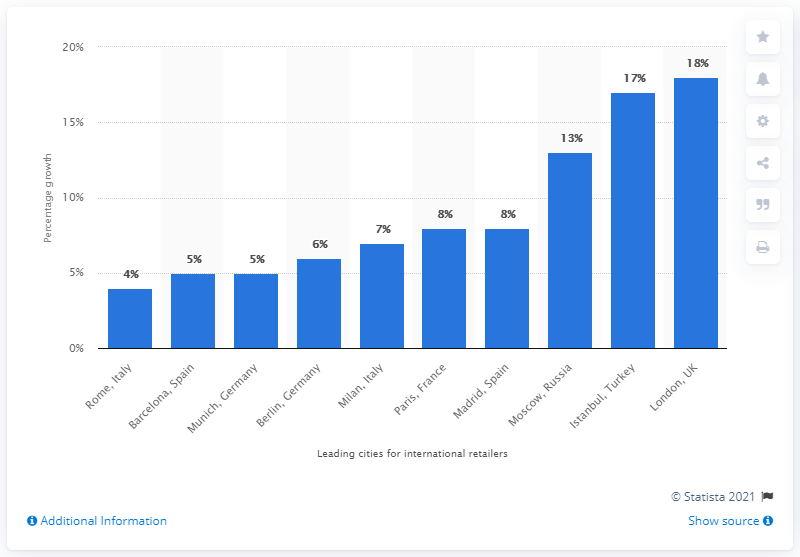Point out several critical features in this image. Barcelona's retail sales are expected to increase by a minimum of 20% from 2014 to 2018. 